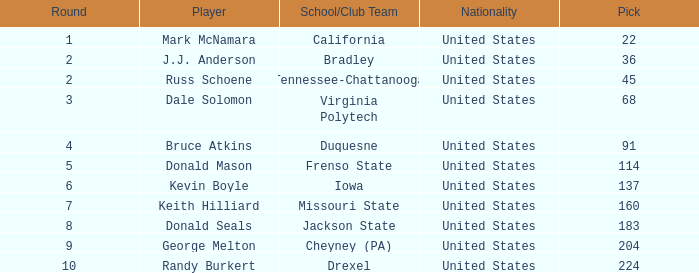What is the earliest round that Donald Mason had a pick larger than 114? None. 